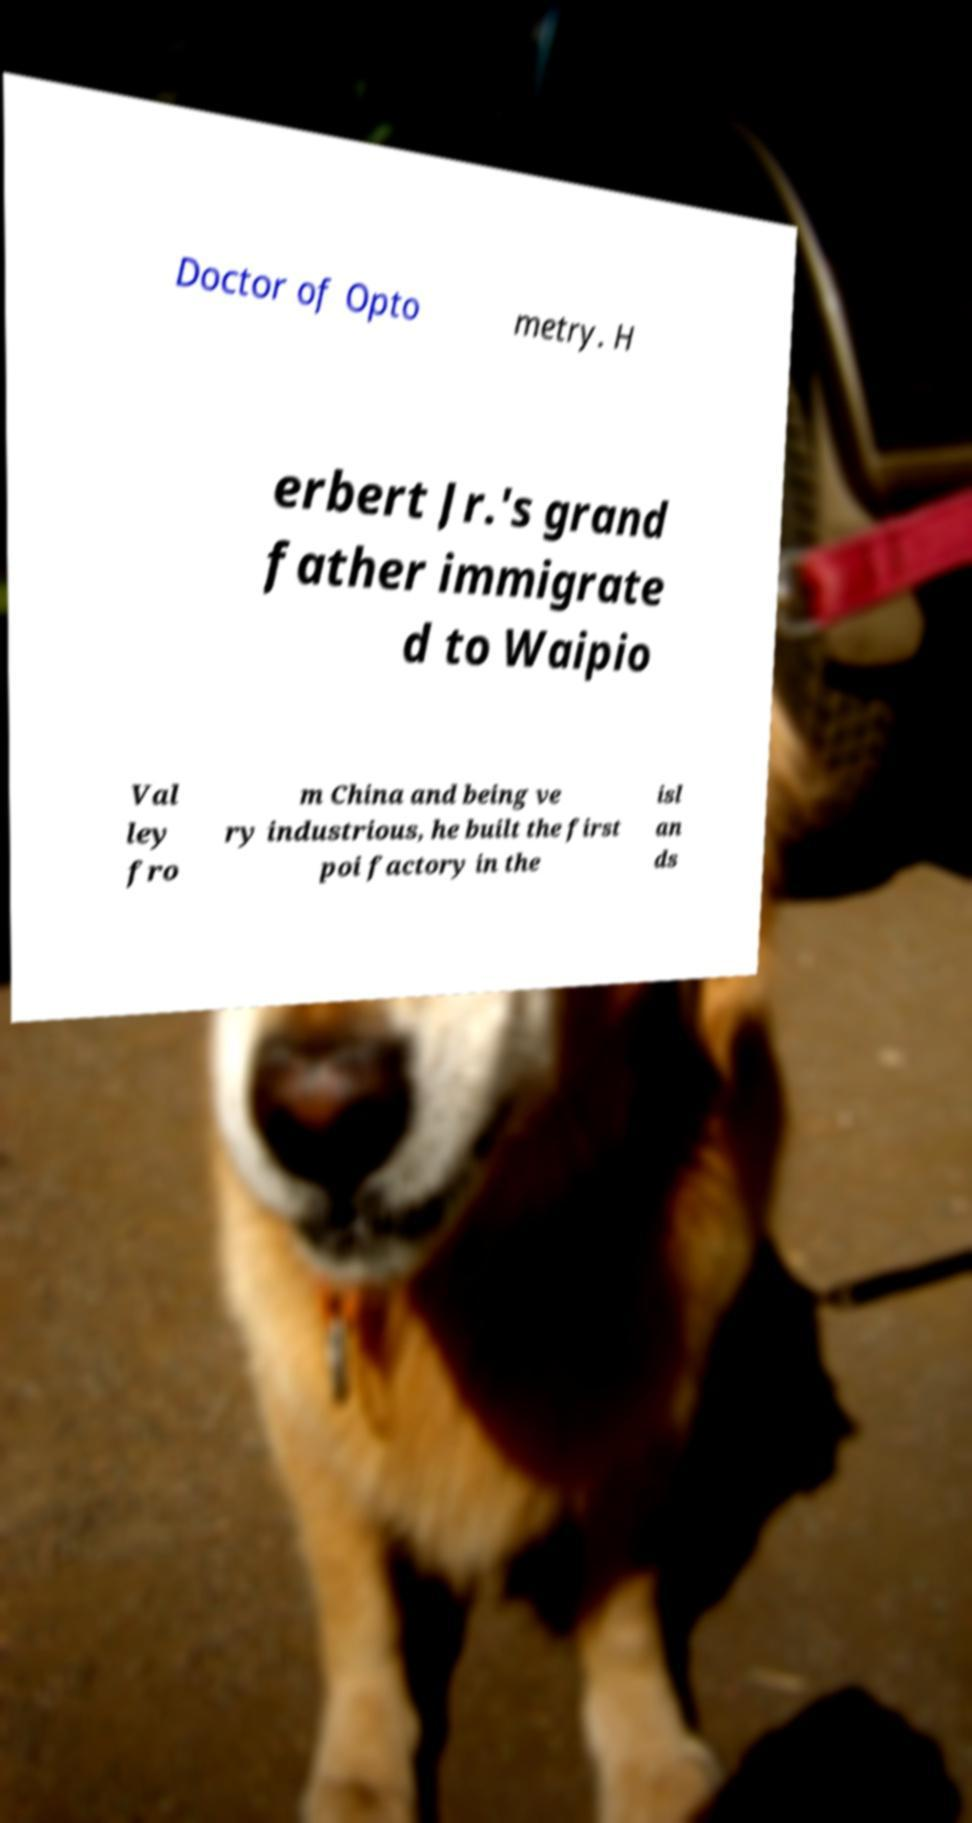Can you accurately transcribe the text from the provided image for me? Doctor of Opto metry. H erbert Jr.'s grand father immigrate d to Waipio Val ley fro m China and being ve ry industrious, he built the first poi factory in the isl an ds 